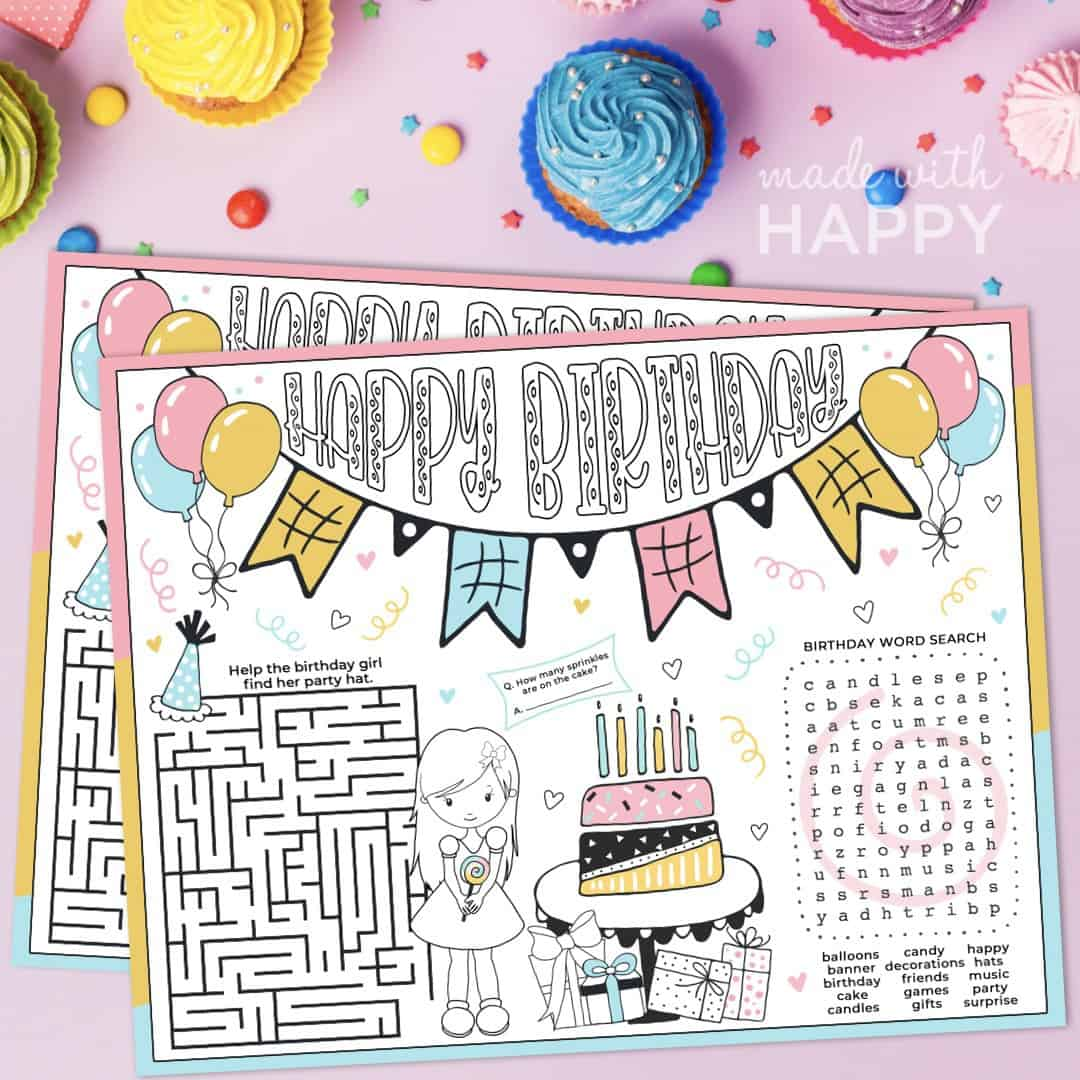What is the color of the birthday girl's dress in the maze activity? The birthday girl's dress in the maze activity is colored white. The rest of the activity sheet is also filled with fun and colorful elements that make the birthday-themed maze engaging for children. 